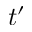<formula> <loc_0><loc_0><loc_500><loc_500>t ^ { \prime }</formula> 